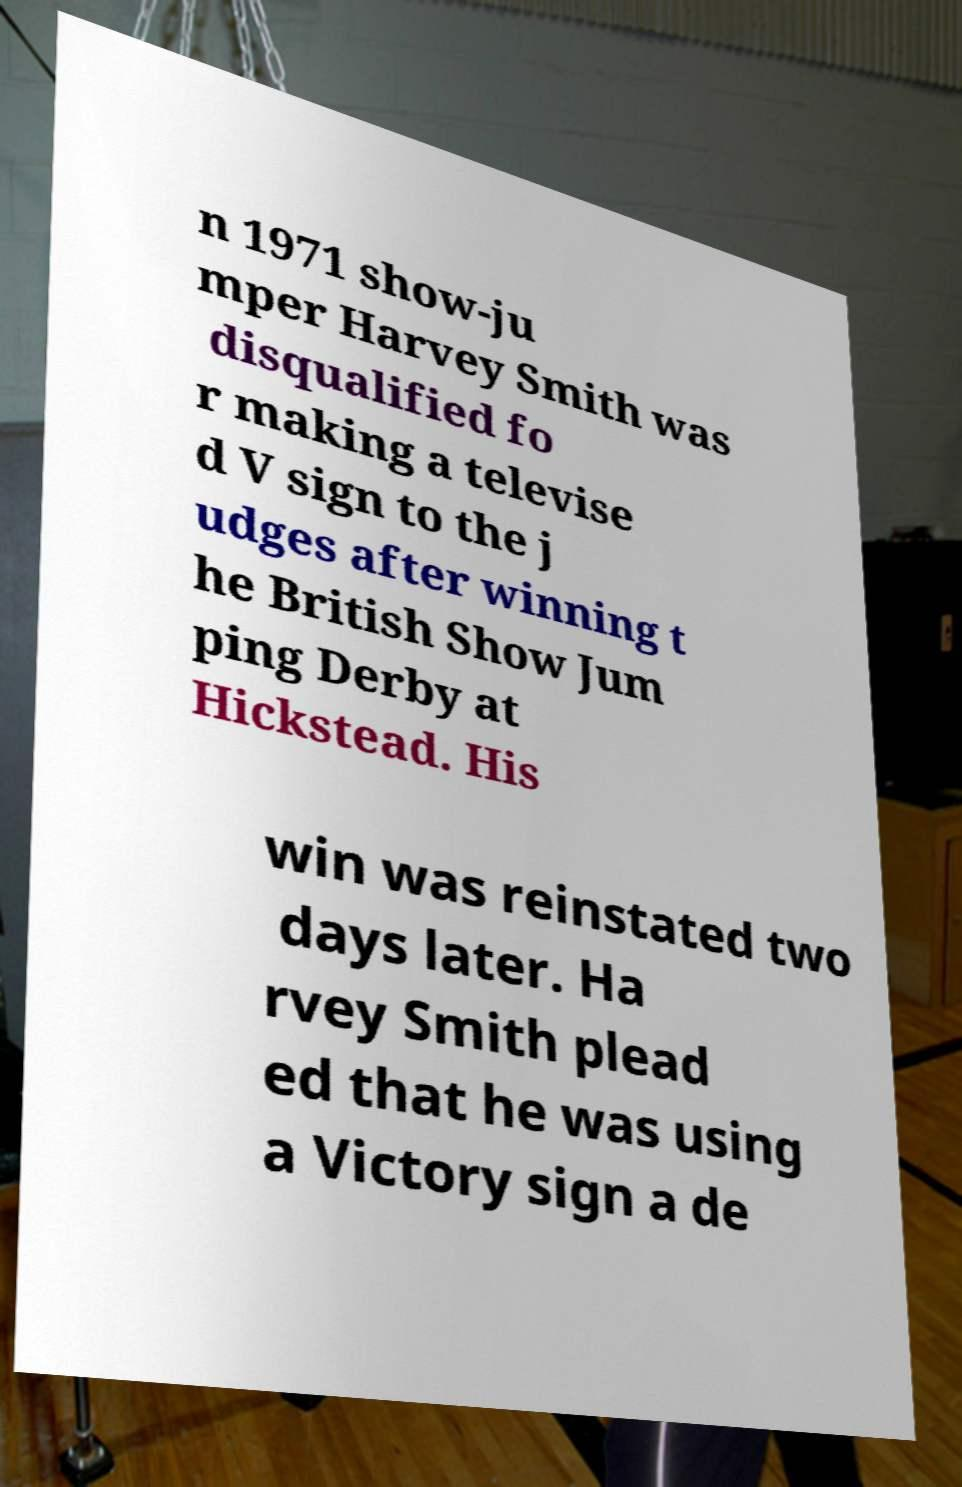Can you read and provide the text displayed in the image?This photo seems to have some interesting text. Can you extract and type it out for me? n 1971 show-ju mper Harvey Smith was disqualified fo r making a televise d V sign to the j udges after winning t he British Show Jum ping Derby at Hickstead. His win was reinstated two days later. Ha rvey Smith plead ed that he was using a Victory sign a de 